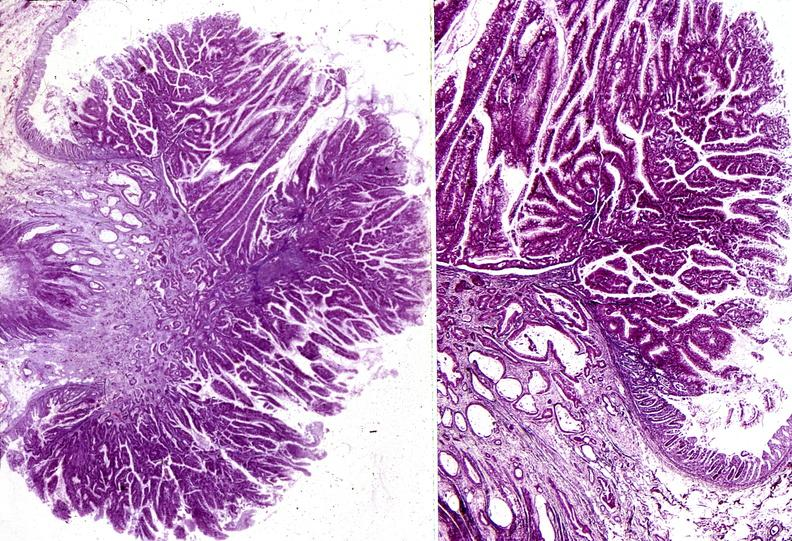s aldehyde fuscin present?
Answer the question using a single word or phrase. No 